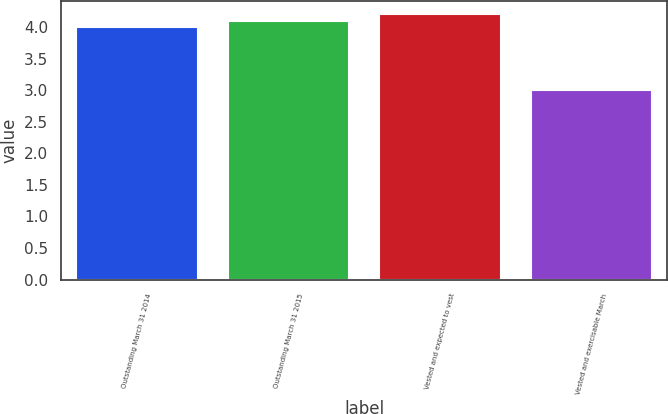<chart> <loc_0><loc_0><loc_500><loc_500><bar_chart><fcel>Outstanding March 31 2014<fcel>Outstanding March 31 2015<fcel>Vested and expected to vest<fcel>Vested and exercisable March<nl><fcel>4<fcel>4.1<fcel>4.2<fcel>3<nl></chart> 